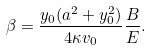Convert formula to latex. <formula><loc_0><loc_0><loc_500><loc_500>\beta = \frac { y _ { 0 } ( a ^ { 2 } + y _ { 0 } ^ { 2 } ) } { 4 \kappa v _ { 0 } } \frac { B } { E } .</formula> 